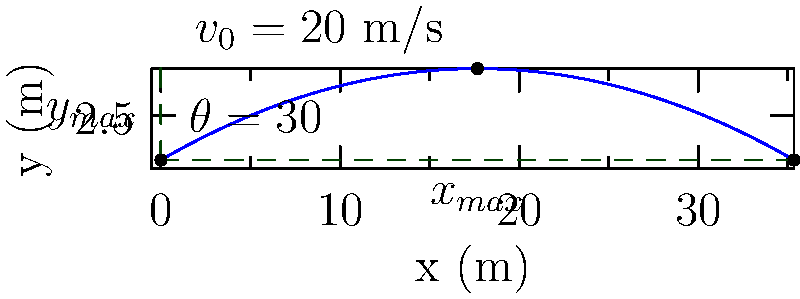A projectile is launched from ground level with an initial velocity of 20 m/s at an angle of 30° above the horizontal. Neglecting air resistance, calculate the maximum height reached by the projectile. How does this relate to the concept of energy conservation in projectile motion? To solve this problem, we'll use the equations of motion for projectile motion and the concept of energy conservation. Let's break it down step-by-step:

1) First, we need to find the vertical component of the initial velocity:
   $v_{0y} = v_0 \sin(\theta) = 20 \sin(30°) = 10$ m/s

2) The maximum height is reached when the vertical velocity becomes zero. We can use the equation:
   $v_y^2 = v_{0y}^2 - 2gy$
   Where $v_y = 0$ at the maximum height, $y = y_{max}$, and $g = 9.8$ m/s².

3) Substituting these values:
   $0 = (10)^2 - 2(9.8)y_{max}$
   $y_{max} = \frac{10^2}{2(9.8)} = 5.1$ m

4) We can verify this using the time to reach maximum height:
   $t = \frac{v_{0y}}{g} = \frac{10}{9.8} = 1.02$ s
   $y_{max} = v_{0y}t - \frac{1}{2}gt^2 = 10(1.02) - \frac{1}{2}(9.8)(1.02)^2 = 5.1$ m

5) Relating to energy conservation:
   At the launch point, the projectile has kinetic energy (KE) and no potential energy (PE).
   At the maximum height, all the vertical component of KE has been converted to PE.

6) We can calculate this:
   Initial vertical KE = $\frac{1}{2}m(v_{0y})^2 = \frac{1}{2}m(10)^2 = 50m$ J
   PE at max height = $mgy_{max} = m(9.8)(5.1) = 50m$ J

This demonstrates that the initial vertical kinetic energy is fully converted to gravitational potential energy at the maximum height, in accordance with the principle of energy conservation.
Answer: Maximum height: 5.1 m. This height represents the point where initial vertical kinetic energy is fully converted to gravitational potential energy. 